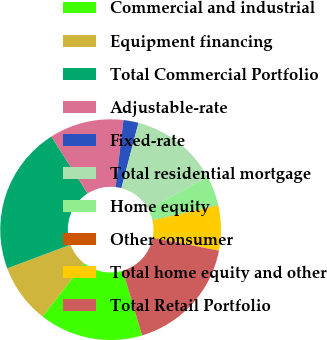Convert chart. <chart><loc_0><loc_0><loc_500><loc_500><pie_chart><fcel>Commercial and industrial<fcel>Equipment financing<fcel>Total Commercial Portfolio<fcel>Adjustable-rate<fcel>Fixed-rate<fcel>Total residential mortgage<fcel>Home equity<fcel>Other consumer<fcel>Total home equity and other<fcel>Total Retail Portfolio<nl><fcel>15.2%<fcel>8.7%<fcel>21.69%<fcel>10.87%<fcel>2.21%<fcel>13.03%<fcel>4.37%<fcel>0.04%<fcel>6.54%<fcel>17.36%<nl></chart> 